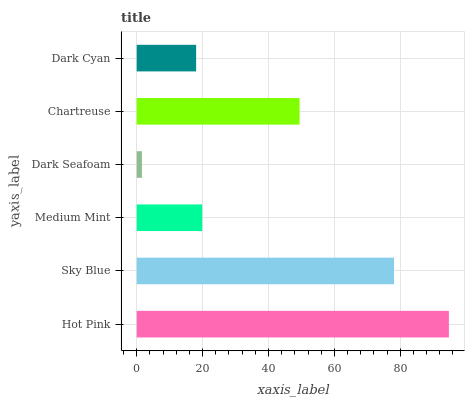Is Dark Seafoam the minimum?
Answer yes or no. Yes. Is Hot Pink the maximum?
Answer yes or no. Yes. Is Sky Blue the minimum?
Answer yes or no. No. Is Sky Blue the maximum?
Answer yes or no. No. Is Hot Pink greater than Sky Blue?
Answer yes or no. Yes. Is Sky Blue less than Hot Pink?
Answer yes or no. Yes. Is Sky Blue greater than Hot Pink?
Answer yes or no. No. Is Hot Pink less than Sky Blue?
Answer yes or no. No. Is Chartreuse the high median?
Answer yes or no. Yes. Is Medium Mint the low median?
Answer yes or no. Yes. Is Sky Blue the high median?
Answer yes or no. No. Is Sky Blue the low median?
Answer yes or no. No. 